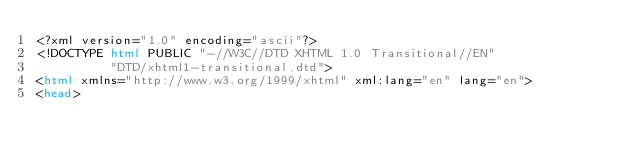Convert code to text. <code><loc_0><loc_0><loc_500><loc_500><_HTML_><?xml version="1.0" encoding="ascii"?>
<!DOCTYPE html PUBLIC "-//W3C//DTD XHTML 1.0 Transitional//EN"
          "DTD/xhtml1-transitional.dtd">
<html xmlns="http://www.w3.org/1999/xhtml" xml:lang="en" lang="en">
<head></code> 